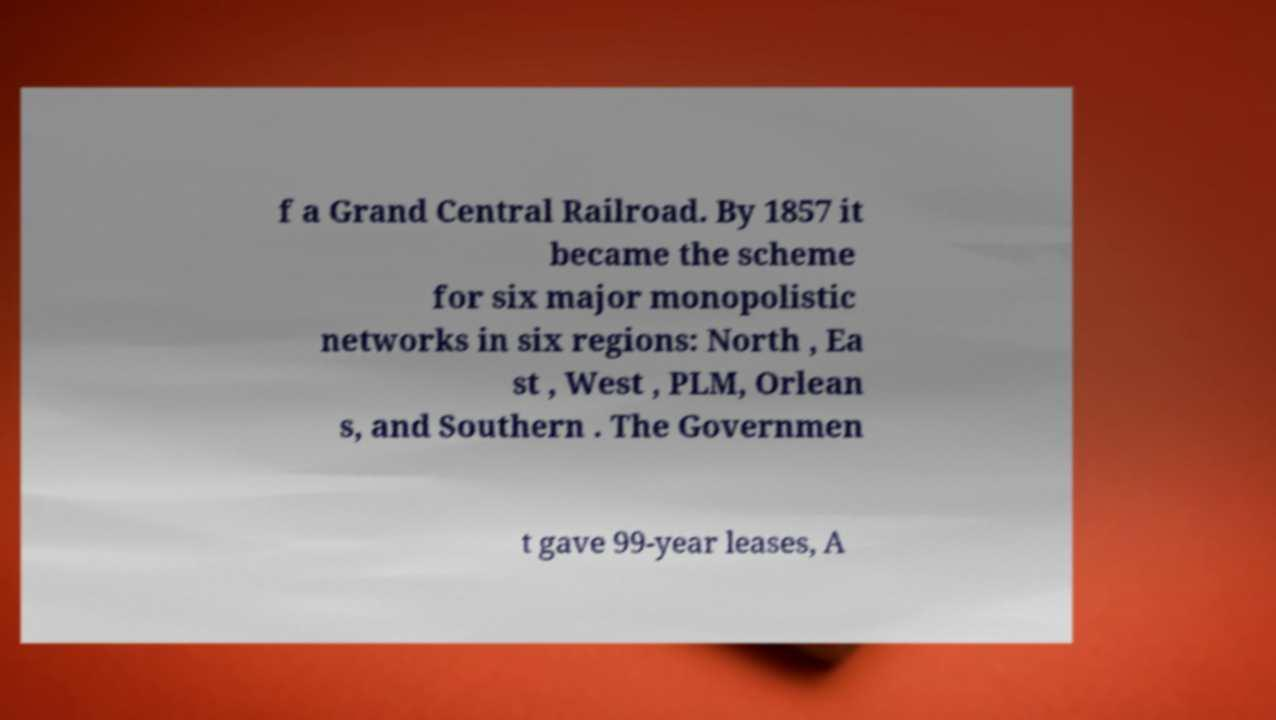Please read and relay the text visible in this image. What does it say? f a Grand Central Railroad. By 1857 it became the scheme for six major monopolistic networks in six regions: North , Ea st , West , PLM, Orlean s, and Southern . The Governmen t gave 99-year leases, A 